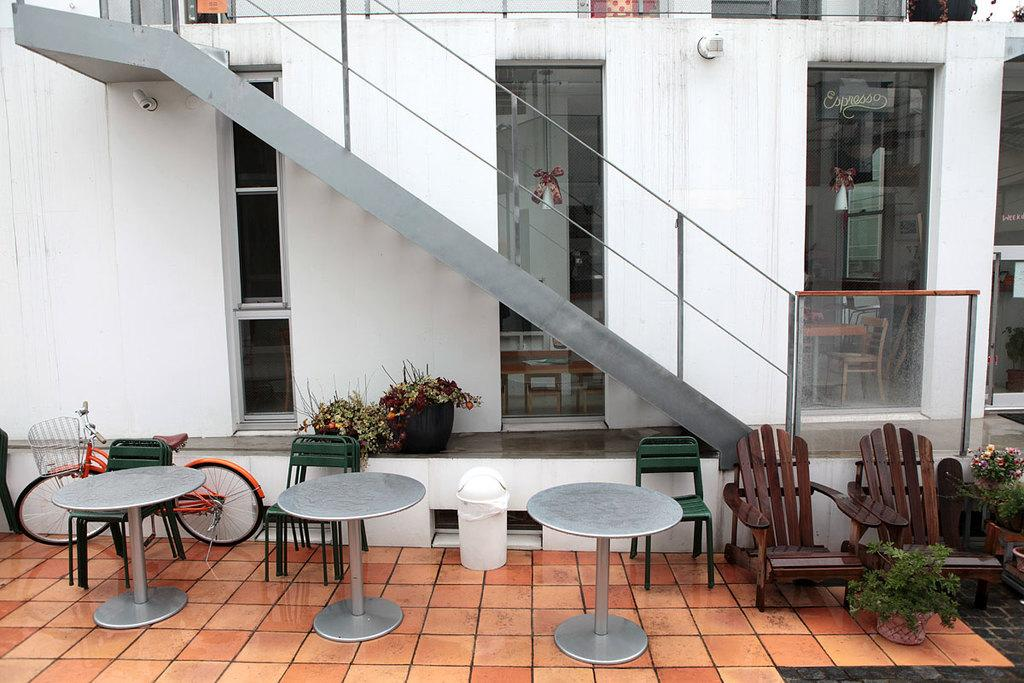What type of furniture is present in the image? There are chairs in the image. What kind of tables are visible in the image? There are circular tables in the image. Are there any decorative elements in the image? Yes, there are plant pots in the image. What architectural feature can be seen in the image? There is a staircase in the image. What type of windows are present in the image? There are glass windows in the image. Can you tell me how many wrens are perched on the plant pots in the image? There are no wrens present in the image; it only features plant pots. What type of pig can be seen walking up the staircase in the image? There is no pig present in the image, and no animals are depicted walking up the staircase. 